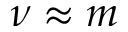Convert formula to latex. <formula><loc_0><loc_0><loc_500><loc_500>\nu \approx m</formula> 